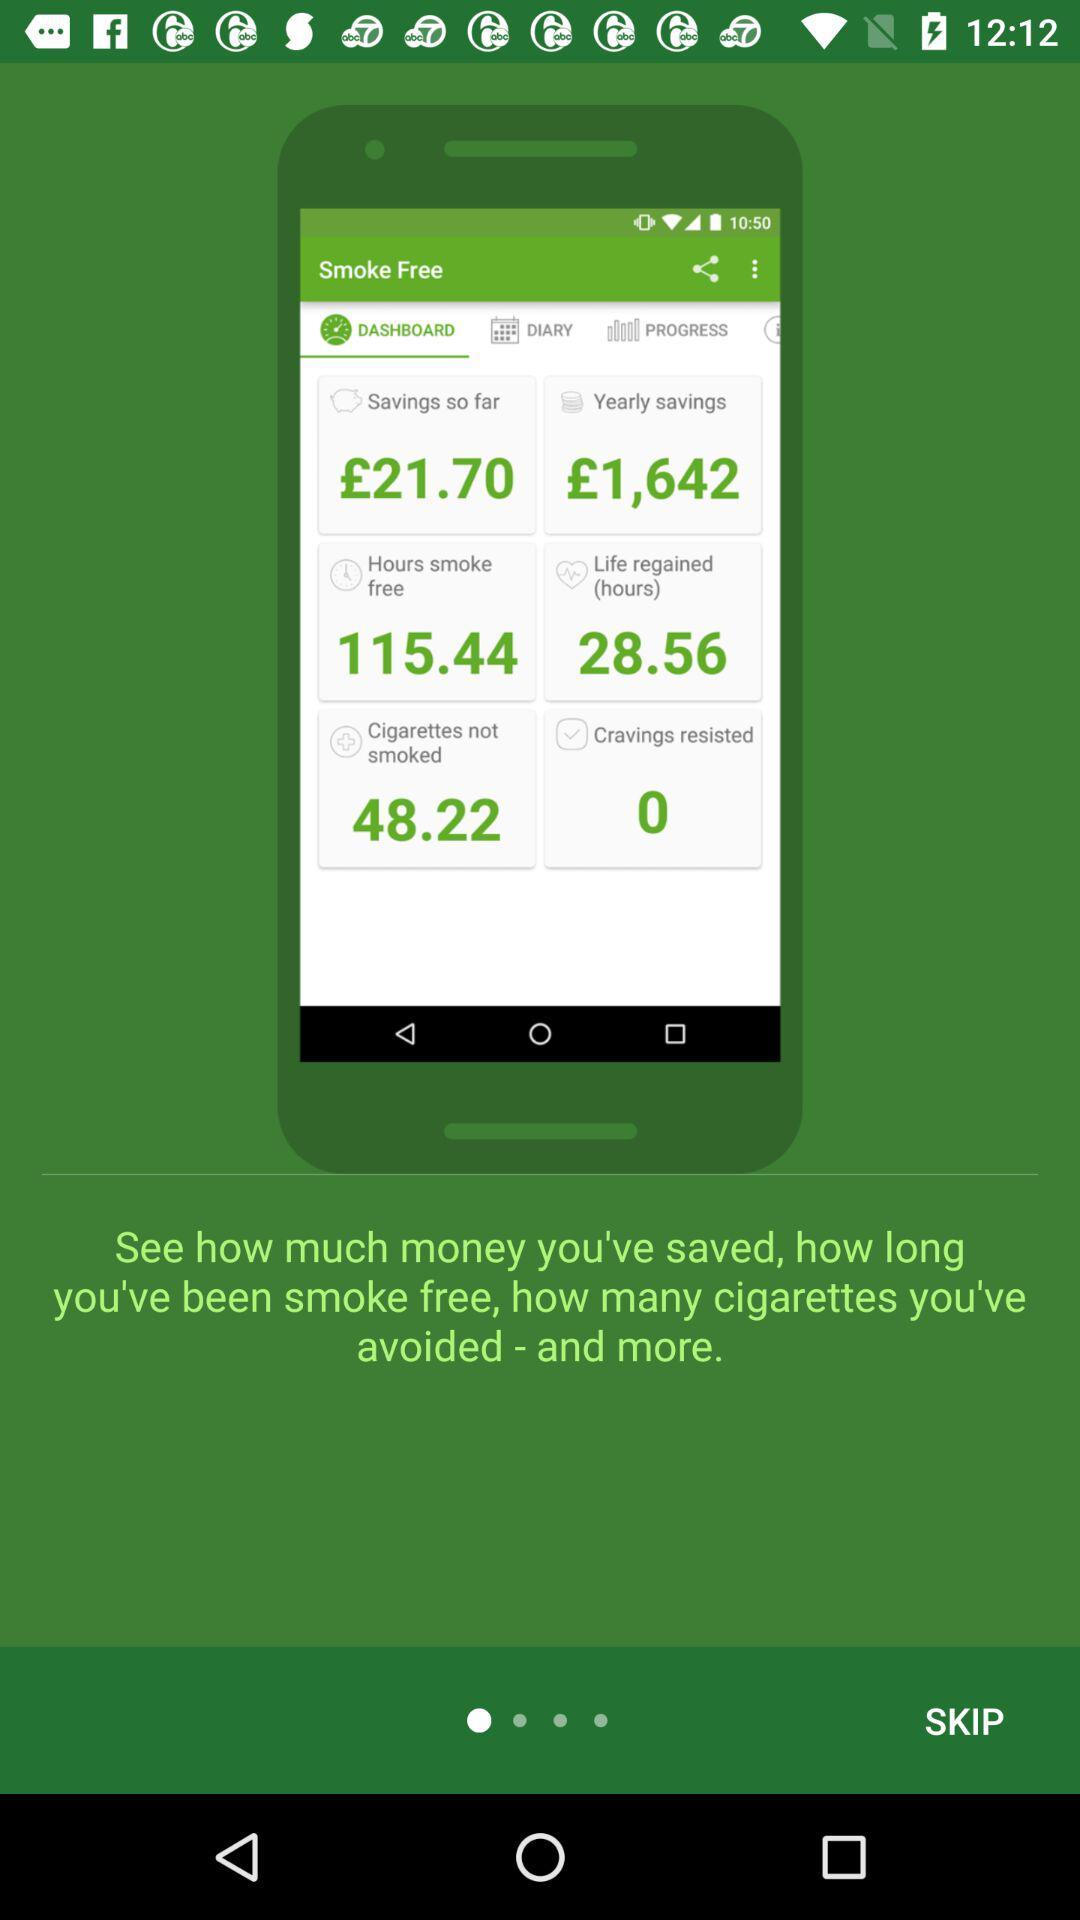How many cigarettes are not smoked? There are 48.22 cigarettes which are not smoked. 